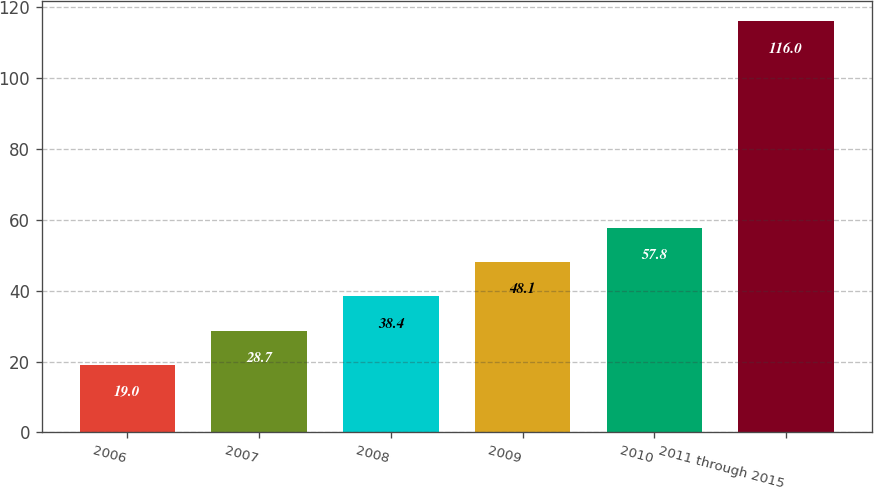<chart> <loc_0><loc_0><loc_500><loc_500><bar_chart><fcel>2006<fcel>2007<fcel>2008<fcel>2009<fcel>2010<fcel>2011 through 2015<nl><fcel>19<fcel>28.7<fcel>38.4<fcel>48.1<fcel>57.8<fcel>116<nl></chart> 